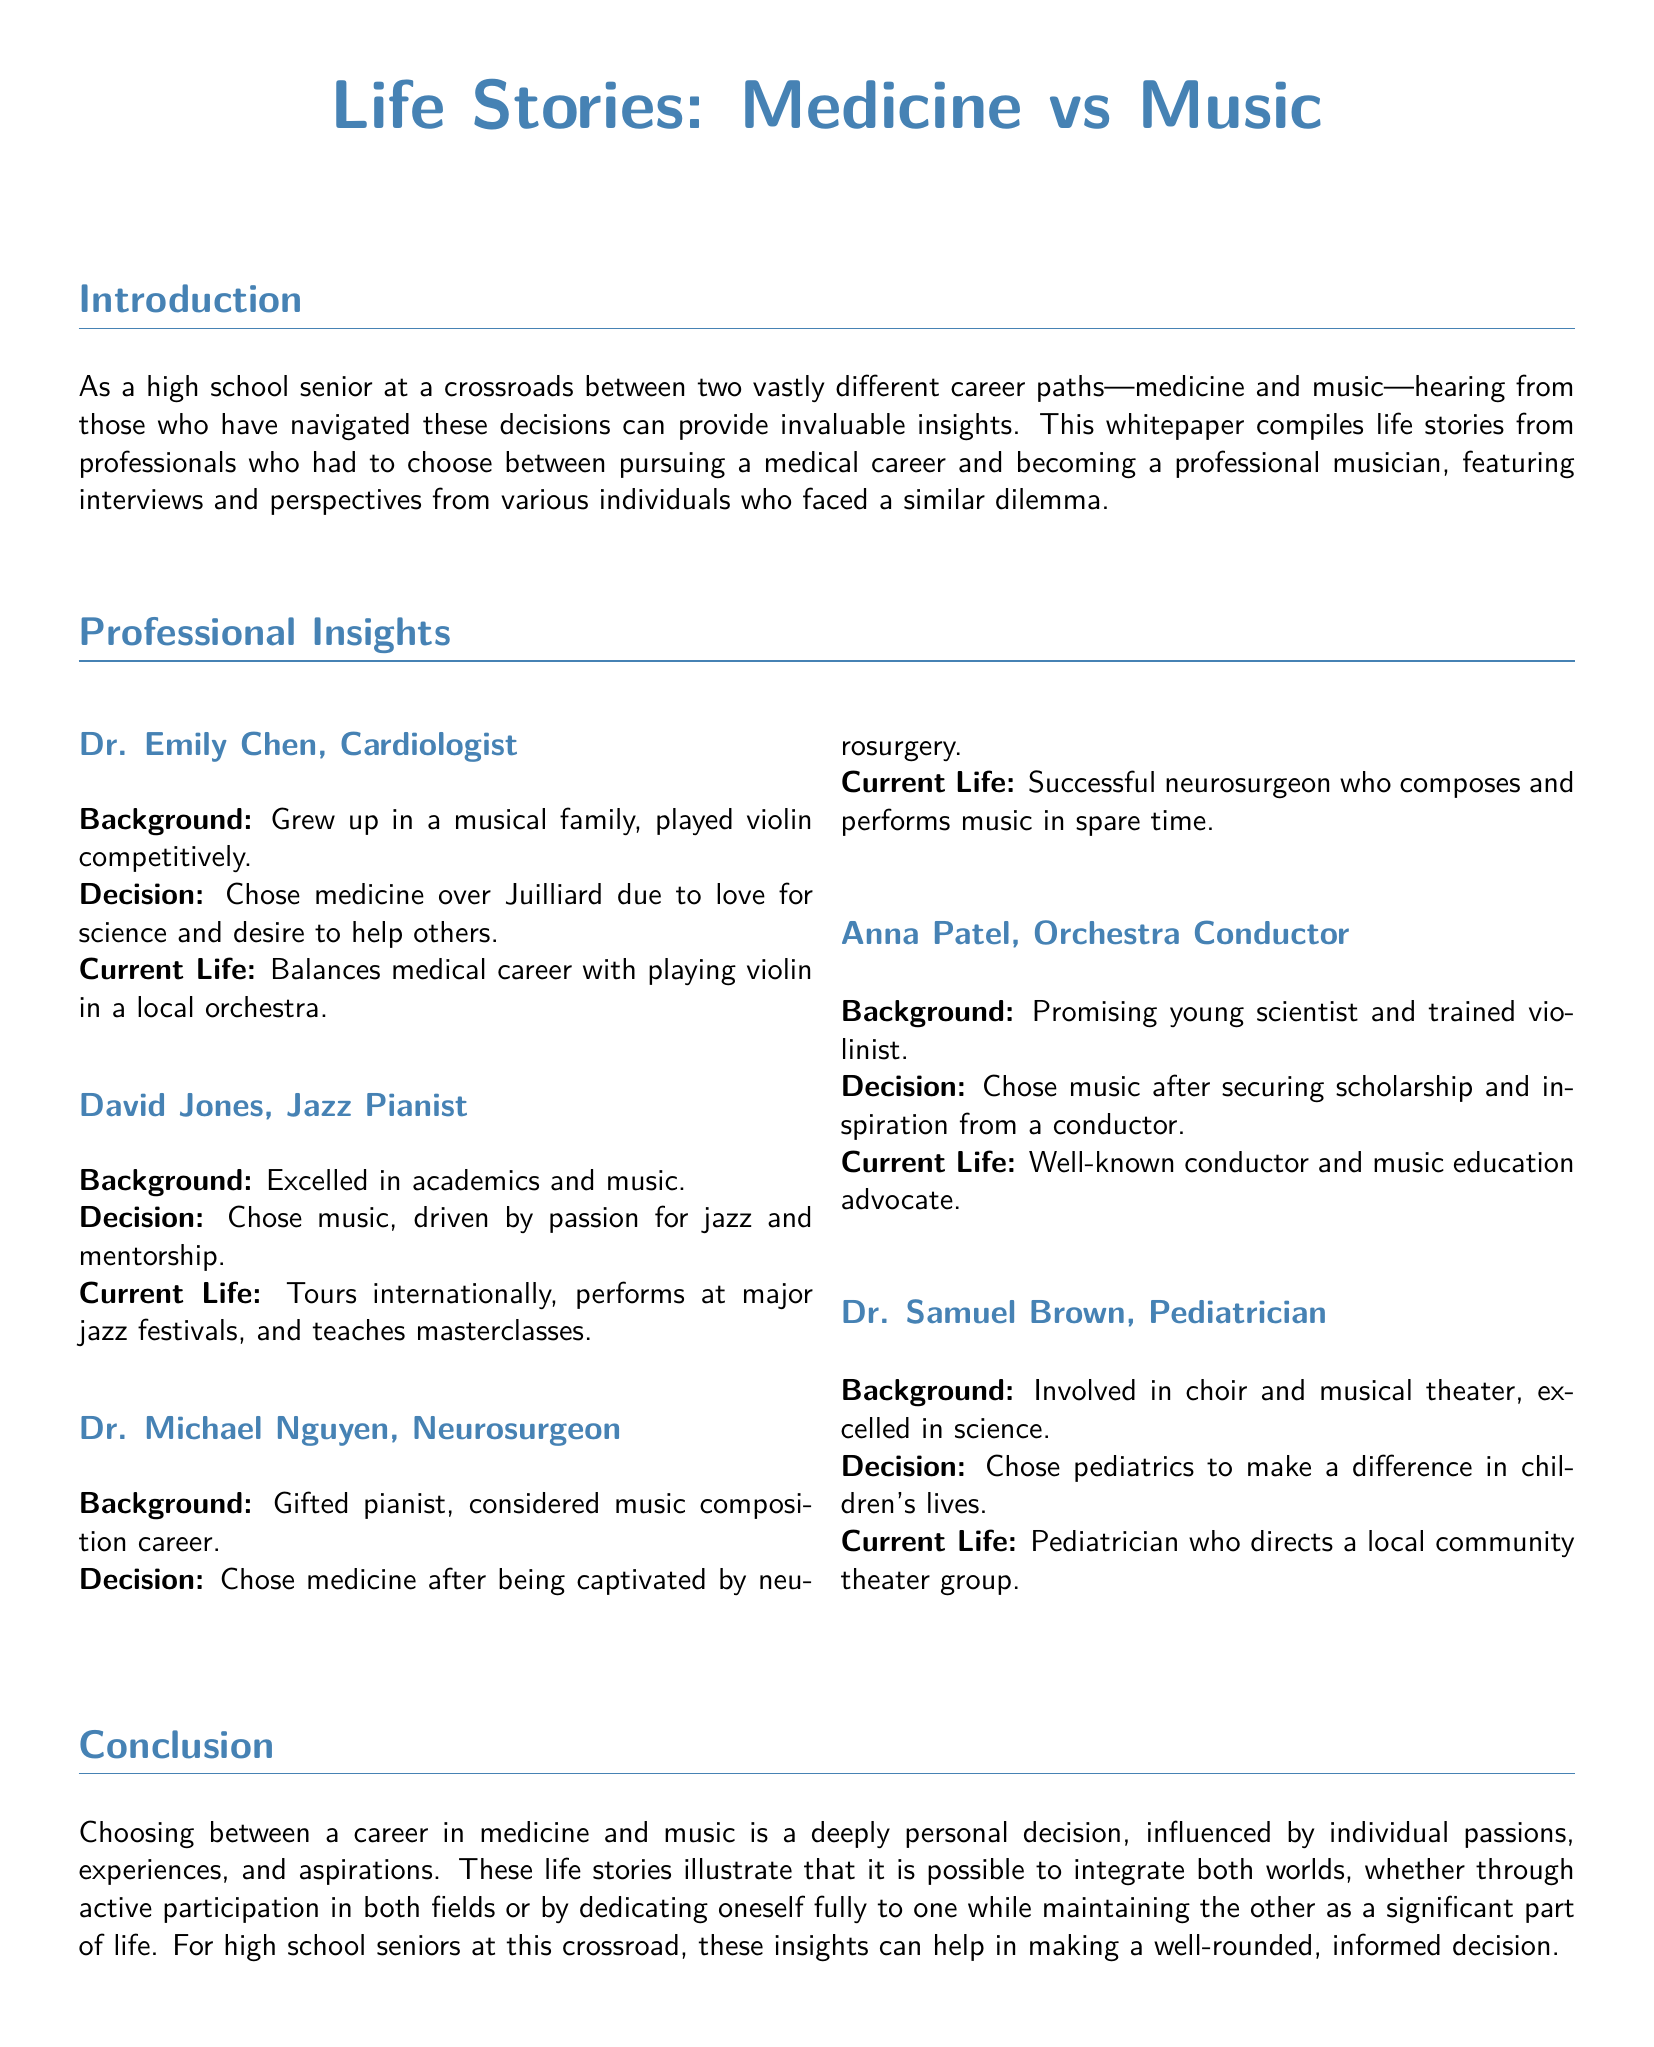what is the title of the whitepaper? The title of the whitepaper is prominently displayed at the top of the document.
Answer: Life Stories: Medicine vs Music who is a well-known conductor mentioned in the document? The document lists Anna Patel as a well-known conductor in the section about her life story.
Answer: Anna Patel how many professionals' stories are featured in the document? The document highlights stories from five different professionals who made choices between medicine and music.
Answer: Five what profession did Dr. Michael Nguyen choose? The document provides information on Dr. Michael Nguyen's profession.
Answer: Neurosurgeon which professional balanced a medical career with music? The document details Dr. Emily Chen's involvement in both medicine and music.
Answer: Dr. Emily Chen what did David Jones pursue over academics? The document mentions David Jones's choice regarding his career path, indicating he prioritized one over the other.
Answer: Music what is the main theme of the whitepaper? The introduction provides insight into the overarching theme of the document.
Answer: Career choices between medicine and music what extracurricular activity was Dr. Samuel Brown involved in? The document states Dr. Samuel Brown's involvement in a specific activity during his youth.
Answer: Choir 